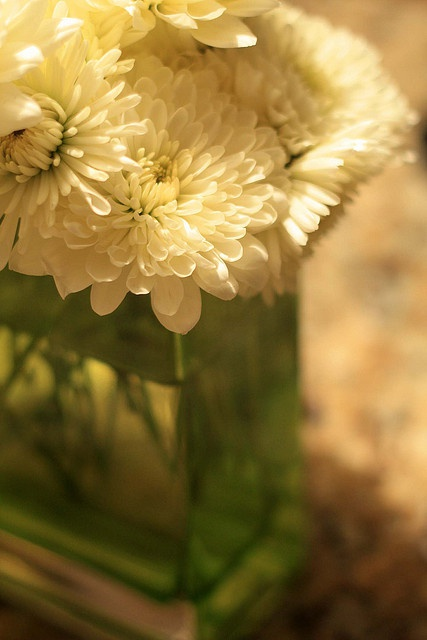Describe the objects in this image and their specific colors. I can see a vase in lightyellow, olive, black, and darkgreen tones in this image. 